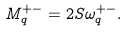Convert formula to latex. <formula><loc_0><loc_0><loc_500><loc_500>M _ { q } ^ { + - } = 2 S \omega _ { q } ^ { + - } .</formula> 